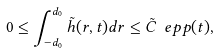Convert formula to latex. <formula><loc_0><loc_0><loc_500><loc_500>0 \leq \int _ { - d _ { 0 } } ^ { d _ { 0 } } \tilde { h } ( r , t ) d r \leq \tilde { C } \ e p p ( t ) ,</formula> 